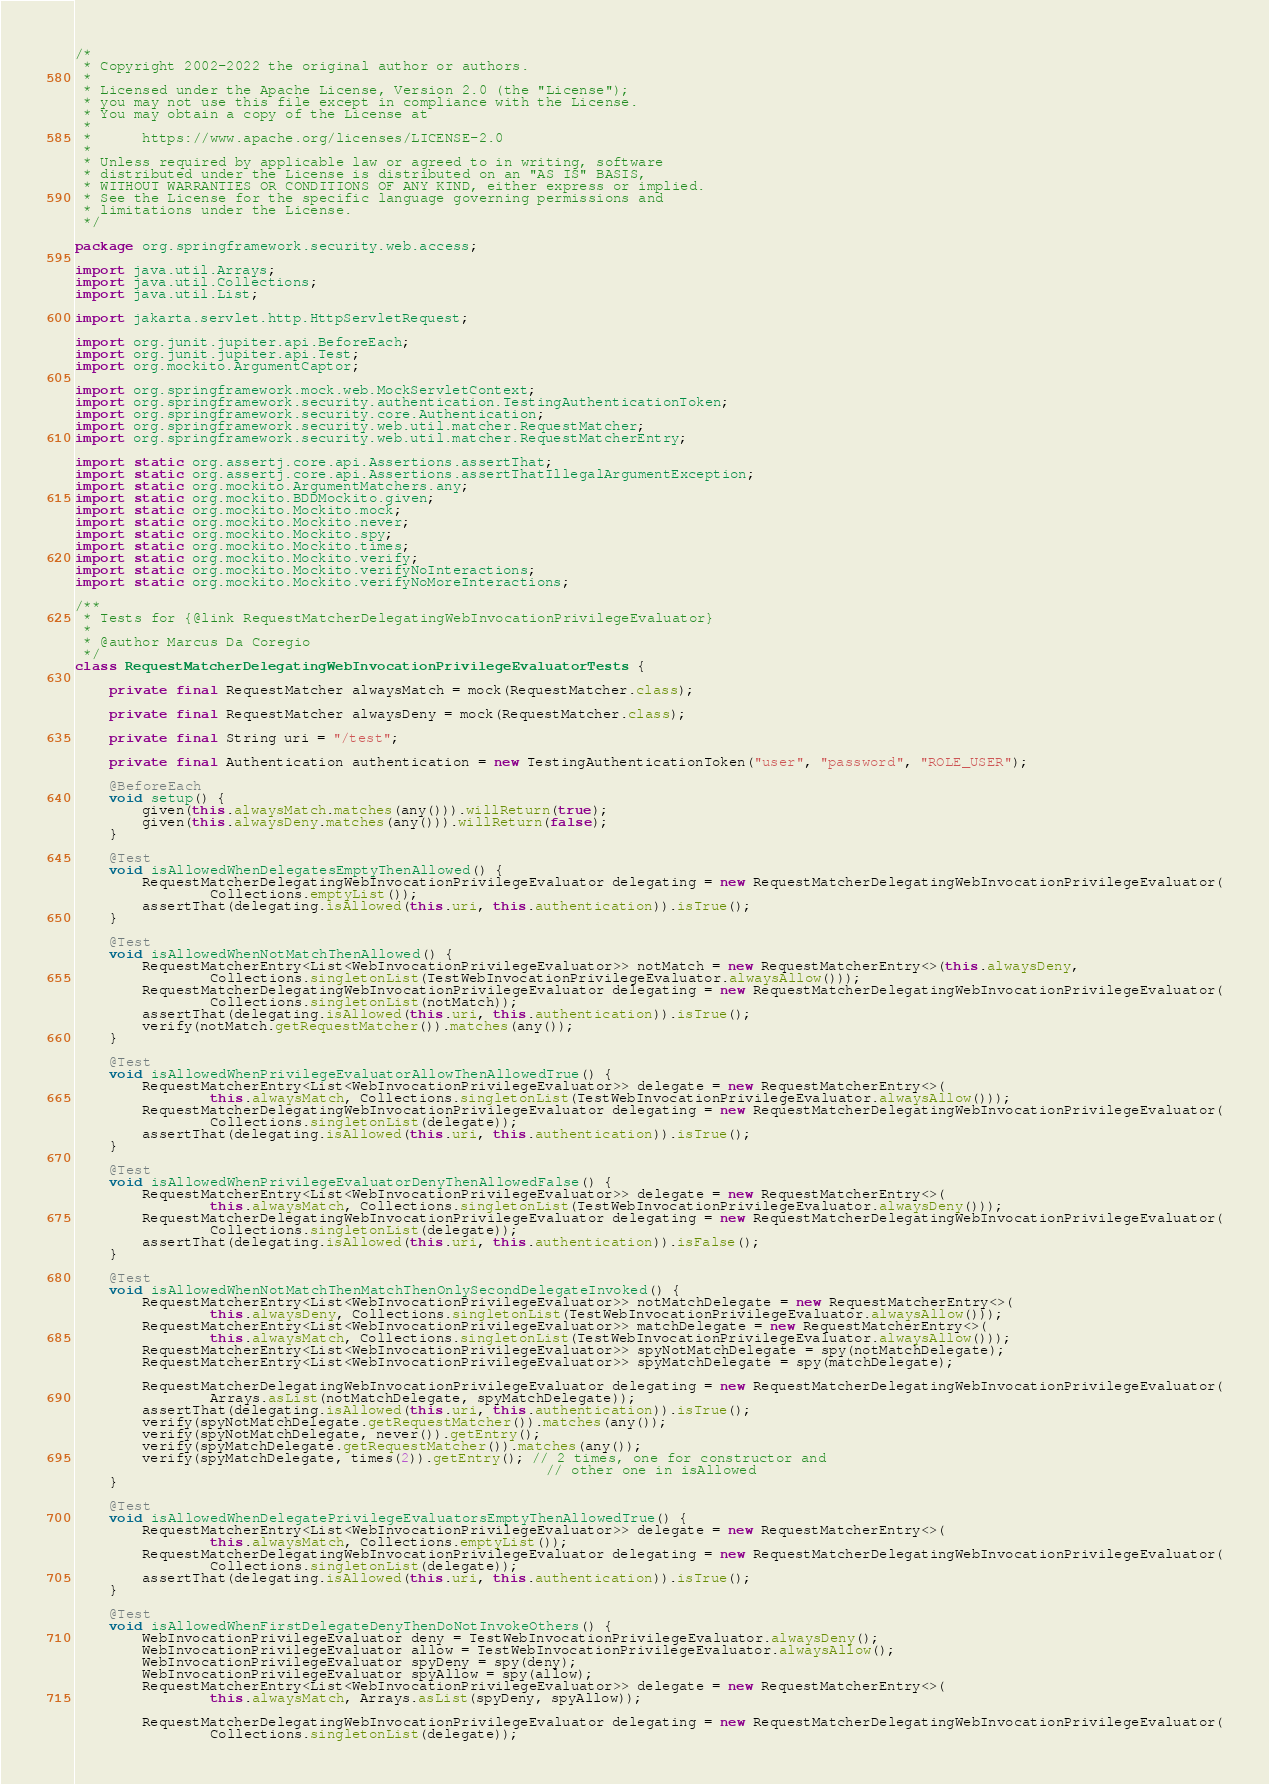Convert code to text. <code><loc_0><loc_0><loc_500><loc_500><_Java_>/*
 * Copyright 2002-2022 the original author or authors.
 *
 * Licensed under the Apache License, Version 2.0 (the "License");
 * you may not use this file except in compliance with the License.
 * You may obtain a copy of the License at
 *
 *      https://www.apache.org/licenses/LICENSE-2.0
 *
 * Unless required by applicable law or agreed to in writing, software
 * distributed under the License is distributed on an "AS IS" BASIS,
 * WITHOUT WARRANTIES OR CONDITIONS OF ANY KIND, either express or implied.
 * See the License for the specific language governing permissions and
 * limitations under the License.
 */

package org.springframework.security.web.access;

import java.util.Arrays;
import java.util.Collections;
import java.util.List;

import jakarta.servlet.http.HttpServletRequest;

import org.junit.jupiter.api.BeforeEach;
import org.junit.jupiter.api.Test;
import org.mockito.ArgumentCaptor;

import org.springframework.mock.web.MockServletContext;
import org.springframework.security.authentication.TestingAuthenticationToken;
import org.springframework.security.core.Authentication;
import org.springframework.security.web.util.matcher.RequestMatcher;
import org.springframework.security.web.util.matcher.RequestMatcherEntry;

import static org.assertj.core.api.Assertions.assertThat;
import static org.assertj.core.api.Assertions.assertThatIllegalArgumentException;
import static org.mockito.ArgumentMatchers.any;
import static org.mockito.BDDMockito.given;
import static org.mockito.Mockito.mock;
import static org.mockito.Mockito.never;
import static org.mockito.Mockito.spy;
import static org.mockito.Mockito.times;
import static org.mockito.Mockito.verify;
import static org.mockito.Mockito.verifyNoInteractions;
import static org.mockito.Mockito.verifyNoMoreInteractions;

/**
 * Tests for {@link RequestMatcherDelegatingWebInvocationPrivilegeEvaluator}
 *
 * @author Marcus Da Coregio
 */
class RequestMatcherDelegatingWebInvocationPrivilegeEvaluatorTests {

	private final RequestMatcher alwaysMatch = mock(RequestMatcher.class);

	private final RequestMatcher alwaysDeny = mock(RequestMatcher.class);

	private final String uri = "/test";

	private final Authentication authentication = new TestingAuthenticationToken("user", "password", "ROLE_USER");

	@BeforeEach
	void setup() {
		given(this.alwaysMatch.matches(any())).willReturn(true);
		given(this.alwaysDeny.matches(any())).willReturn(false);
	}

	@Test
	void isAllowedWhenDelegatesEmptyThenAllowed() {
		RequestMatcherDelegatingWebInvocationPrivilegeEvaluator delegating = new RequestMatcherDelegatingWebInvocationPrivilegeEvaluator(
				Collections.emptyList());
		assertThat(delegating.isAllowed(this.uri, this.authentication)).isTrue();
	}

	@Test
	void isAllowedWhenNotMatchThenAllowed() {
		RequestMatcherEntry<List<WebInvocationPrivilegeEvaluator>> notMatch = new RequestMatcherEntry<>(this.alwaysDeny,
				Collections.singletonList(TestWebInvocationPrivilegeEvaluator.alwaysAllow()));
		RequestMatcherDelegatingWebInvocationPrivilegeEvaluator delegating = new RequestMatcherDelegatingWebInvocationPrivilegeEvaluator(
				Collections.singletonList(notMatch));
		assertThat(delegating.isAllowed(this.uri, this.authentication)).isTrue();
		verify(notMatch.getRequestMatcher()).matches(any());
	}

	@Test
	void isAllowedWhenPrivilegeEvaluatorAllowThenAllowedTrue() {
		RequestMatcherEntry<List<WebInvocationPrivilegeEvaluator>> delegate = new RequestMatcherEntry<>(
				this.alwaysMatch, Collections.singletonList(TestWebInvocationPrivilegeEvaluator.alwaysAllow()));
		RequestMatcherDelegatingWebInvocationPrivilegeEvaluator delegating = new RequestMatcherDelegatingWebInvocationPrivilegeEvaluator(
				Collections.singletonList(delegate));
		assertThat(delegating.isAllowed(this.uri, this.authentication)).isTrue();
	}

	@Test
	void isAllowedWhenPrivilegeEvaluatorDenyThenAllowedFalse() {
		RequestMatcherEntry<List<WebInvocationPrivilegeEvaluator>> delegate = new RequestMatcherEntry<>(
				this.alwaysMatch, Collections.singletonList(TestWebInvocationPrivilegeEvaluator.alwaysDeny()));
		RequestMatcherDelegatingWebInvocationPrivilegeEvaluator delegating = new RequestMatcherDelegatingWebInvocationPrivilegeEvaluator(
				Collections.singletonList(delegate));
		assertThat(delegating.isAllowed(this.uri, this.authentication)).isFalse();
	}

	@Test
	void isAllowedWhenNotMatchThenMatchThenOnlySecondDelegateInvoked() {
		RequestMatcherEntry<List<WebInvocationPrivilegeEvaluator>> notMatchDelegate = new RequestMatcherEntry<>(
				this.alwaysDeny, Collections.singletonList(TestWebInvocationPrivilegeEvaluator.alwaysAllow()));
		RequestMatcherEntry<List<WebInvocationPrivilegeEvaluator>> matchDelegate = new RequestMatcherEntry<>(
				this.alwaysMatch, Collections.singletonList(TestWebInvocationPrivilegeEvaluator.alwaysAllow()));
		RequestMatcherEntry<List<WebInvocationPrivilegeEvaluator>> spyNotMatchDelegate = spy(notMatchDelegate);
		RequestMatcherEntry<List<WebInvocationPrivilegeEvaluator>> spyMatchDelegate = spy(matchDelegate);

		RequestMatcherDelegatingWebInvocationPrivilegeEvaluator delegating = new RequestMatcherDelegatingWebInvocationPrivilegeEvaluator(
				Arrays.asList(notMatchDelegate, spyMatchDelegate));
		assertThat(delegating.isAllowed(this.uri, this.authentication)).isTrue();
		verify(spyNotMatchDelegate.getRequestMatcher()).matches(any());
		verify(spyNotMatchDelegate, never()).getEntry();
		verify(spyMatchDelegate.getRequestMatcher()).matches(any());
		verify(spyMatchDelegate, times(2)).getEntry(); // 2 times, one for constructor and
														// other one in isAllowed
	}

	@Test
	void isAllowedWhenDelegatePrivilegeEvaluatorsEmptyThenAllowedTrue() {
		RequestMatcherEntry<List<WebInvocationPrivilegeEvaluator>> delegate = new RequestMatcherEntry<>(
				this.alwaysMatch, Collections.emptyList());
		RequestMatcherDelegatingWebInvocationPrivilegeEvaluator delegating = new RequestMatcherDelegatingWebInvocationPrivilegeEvaluator(
				Collections.singletonList(delegate));
		assertThat(delegating.isAllowed(this.uri, this.authentication)).isTrue();
	}

	@Test
	void isAllowedWhenFirstDelegateDenyThenDoNotInvokeOthers() {
		WebInvocationPrivilegeEvaluator deny = TestWebInvocationPrivilegeEvaluator.alwaysDeny();
		WebInvocationPrivilegeEvaluator allow = TestWebInvocationPrivilegeEvaluator.alwaysAllow();
		WebInvocationPrivilegeEvaluator spyDeny = spy(deny);
		WebInvocationPrivilegeEvaluator spyAllow = spy(allow);
		RequestMatcherEntry<List<WebInvocationPrivilegeEvaluator>> delegate = new RequestMatcherEntry<>(
				this.alwaysMatch, Arrays.asList(spyDeny, spyAllow));

		RequestMatcherDelegatingWebInvocationPrivilegeEvaluator delegating = new RequestMatcherDelegatingWebInvocationPrivilegeEvaluator(
				Collections.singletonList(delegate));
</code> 